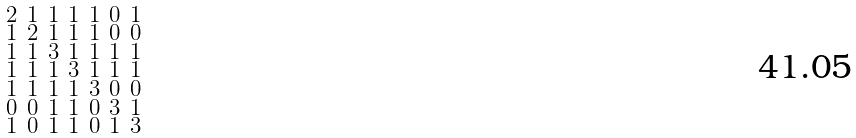<formula> <loc_0><loc_0><loc_500><loc_500>\begin{smallmatrix} 2 & 1 & 1 & 1 & 1 & 0 & 1 \\ 1 & 2 & 1 & 1 & 1 & 0 & 0 \\ 1 & 1 & 3 & 1 & 1 & 1 & 1 \\ 1 & 1 & 1 & 3 & 1 & 1 & 1 \\ 1 & 1 & 1 & 1 & 3 & 0 & 0 \\ 0 & 0 & 1 & 1 & 0 & 3 & 1 \\ 1 & 0 & 1 & 1 & 0 & 1 & 3 \end{smallmatrix}</formula> 